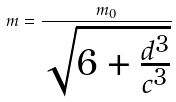<formula> <loc_0><loc_0><loc_500><loc_500>m = \frac { m _ { 0 } } { \sqrt { 6 + \frac { d ^ { 3 } } { c ^ { 3 } } } }</formula> 